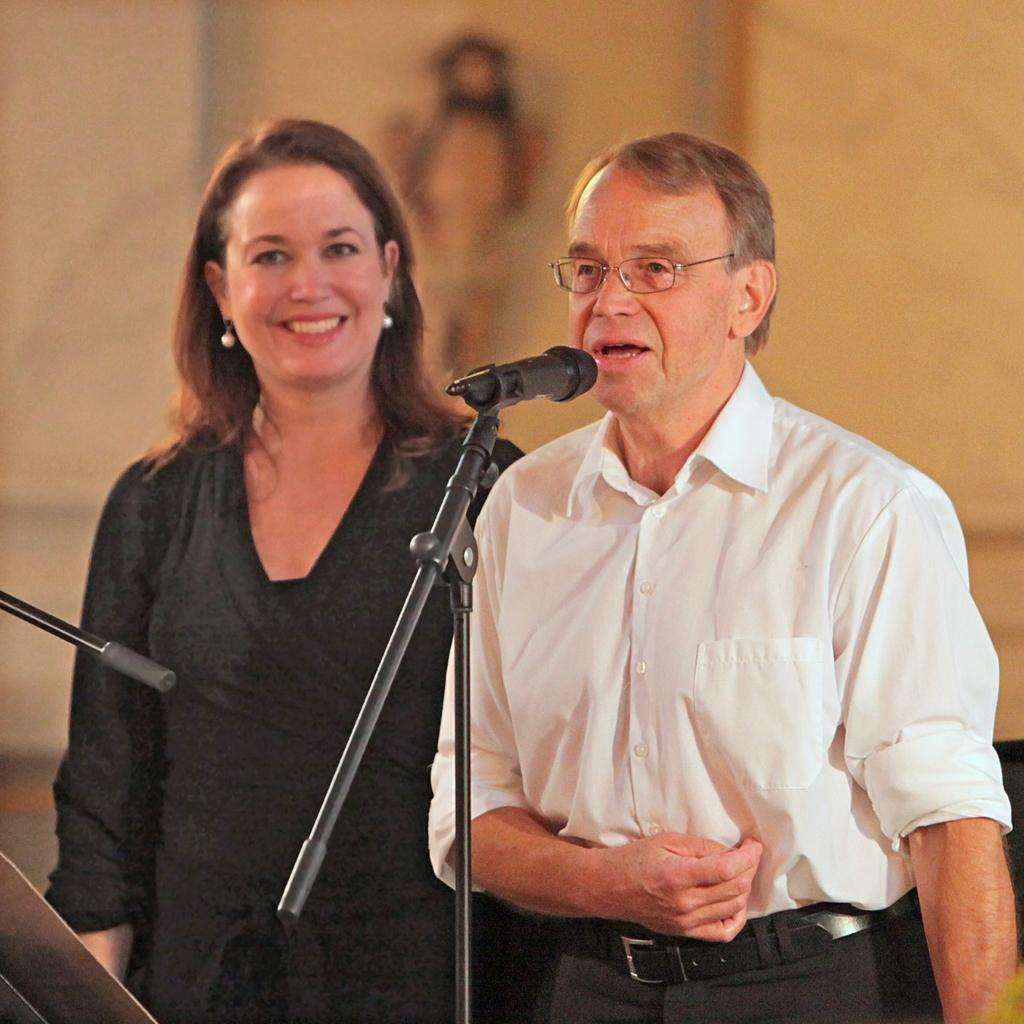How many people are in the image? There are two people in the image. What are the people doing in the image? The people are standing. What are the people wearing in the image? The people are wearing different color dresses. What objects can be seen in the image besides the people? There is a mic and a stand in the image. Can you describe the background of the image? The background of the image is blurred. How many bushes can be seen in the image? There are no bushes visible in the image. What type of dime is present in the image? There is no dime present in the image. 